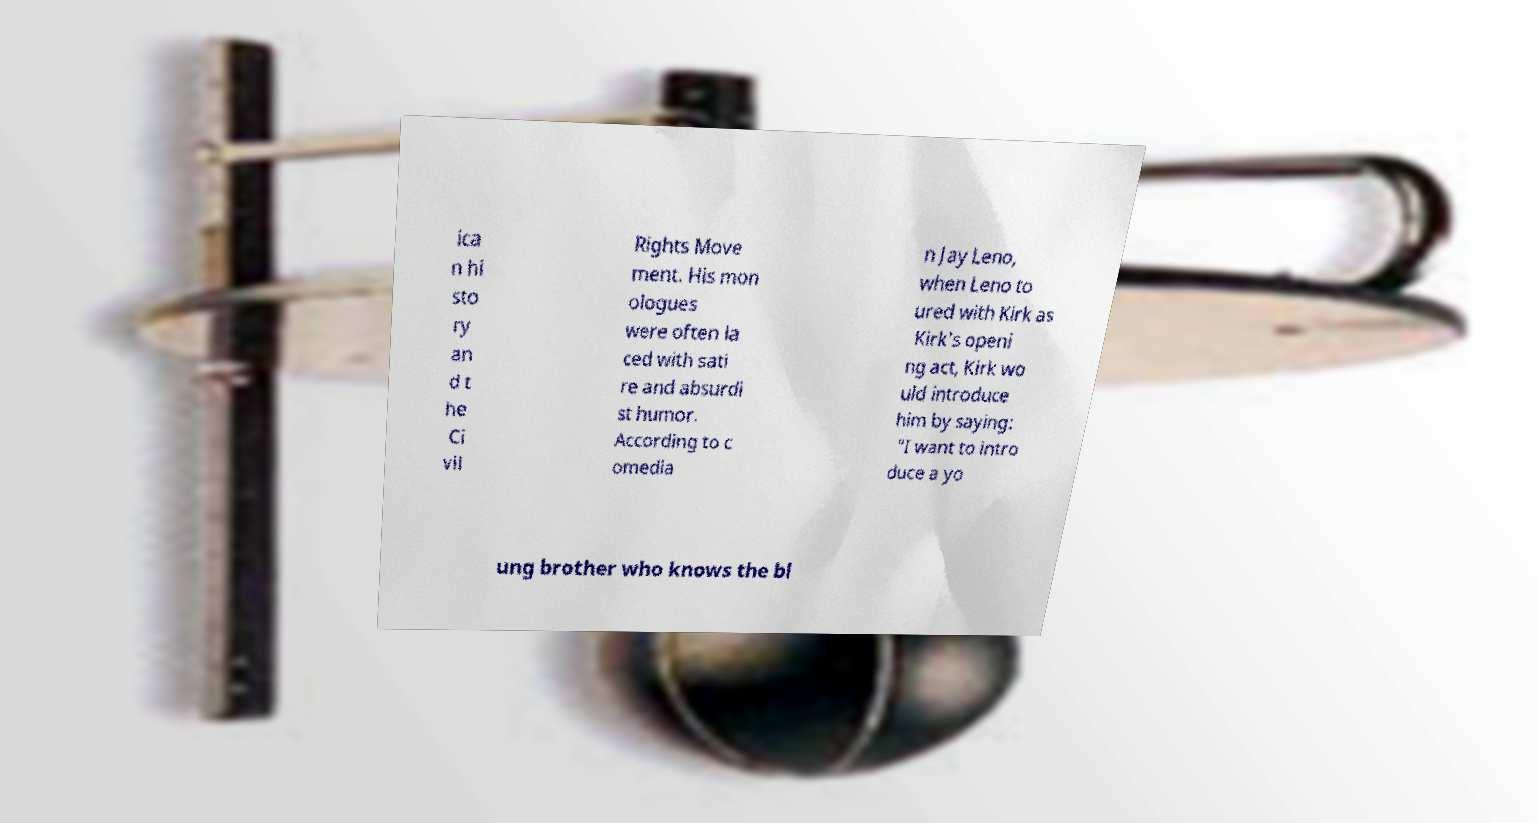For documentation purposes, I need the text within this image transcribed. Could you provide that? ica n hi sto ry an d t he Ci vil Rights Move ment. His mon ologues were often la ced with sati re and absurdi st humor. According to c omedia n Jay Leno, when Leno to ured with Kirk as Kirk's openi ng act, Kirk wo uld introduce him by saying: "I want to intro duce a yo ung brother who knows the bl 